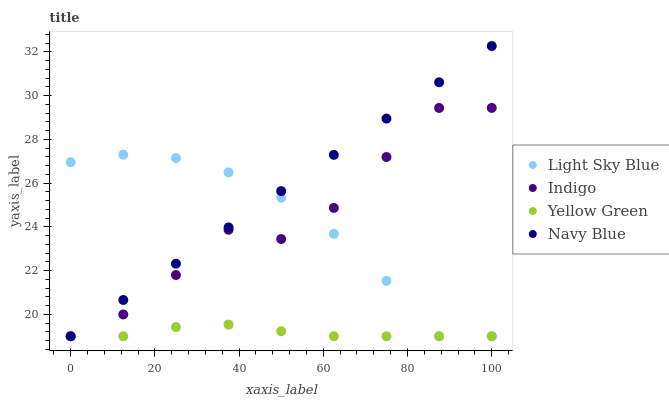Does Yellow Green have the minimum area under the curve?
Answer yes or no. Yes. Does Navy Blue have the maximum area under the curve?
Answer yes or no. Yes. Does Light Sky Blue have the minimum area under the curve?
Answer yes or no. No. Does Light Sky Blue have the maximum area under the curve?
Answer yes or no. No. Is Navy Blue the smoothest?
Answer yes or no. Yes. Is Indigo the roughest?
Answer yes or no. Yes. Is Light Sky Blue the smoothest?
Answer yes or no. No. Is Light Sky Blue the roughest?
Answer yes or no. No. Does Navy Blue have the lowest value?
Answer yes or no. Yes. Does Navy Blue have the highest value?
Answer yes or no. Yes. Does Light Sky Blue have the highest value?
Answer yes or no. No. Does Yellow Green intersect Navy Blue?
Answer yes or no. Yes. Is Yellow Green less than Navy Blue?
Answer yes or no. No. Is Yellow Green greater than Navy Blue?
Answer yes or no. No. 